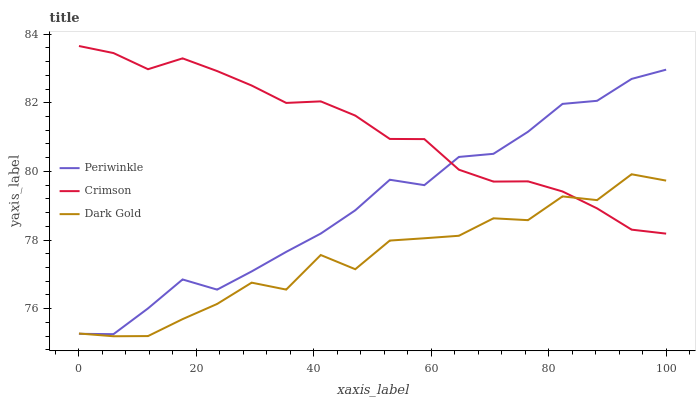Does Dark Gold have the minimum area under the curve?
Answer yes or no. Yes. Does Crimson have the maximum area under the curve?
Answer yes or no. Yes. Does Periwinkle have the minimum area under the curve?
Answer yes or no. No. Does Periwinkle have the maximum area under the curve?
Answer yes or no. No. Is Crimson the smoothest?
Answer yes or no. Yes. Is Dark Gold the roughest?
Answer yes or no. Yes. Is Periwinkle the smoothest?
Answer yes or no. No. Is Periwinkle the roughest?
Answer yes or no. No. Does Dark Gold have the lowest value?
Answer yes or no. Yes. Does Periwinkle have the lowest value?
Answer yes or no. No. Does Crimson have the highest value?
Answer yes or no. Yes. Does Periwinkle have the highest value?
Answer yes or no. No. Does Periwinkle intersect Dark Gold?
Answer yes or no. Yes. Is Periwinkle less than Dark Gold?
Answer yes or no. No. Is Periwinkle greater than Dark Gold?
Answer yes or no. No. 